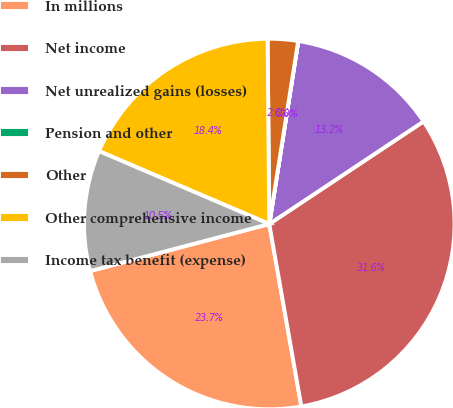Convert chart to OTSL. <chart><loc_0><loc_0><loc_500><loc_500><pie_chart><fcel>In millions<fcel>Net income<fcel>Net unrealized gains (losses)<fcel>Pension and other<fcel>Other<fcel>Other comprehensive income<fcel>Income tax benefit (expense)<nl><fcel>23.68%<fcel>31.57%<fcel>13.16%<fcel>0.01%<fcel>2.64%<fcel>18.42%<fcel>10.53%<nl></chart> 